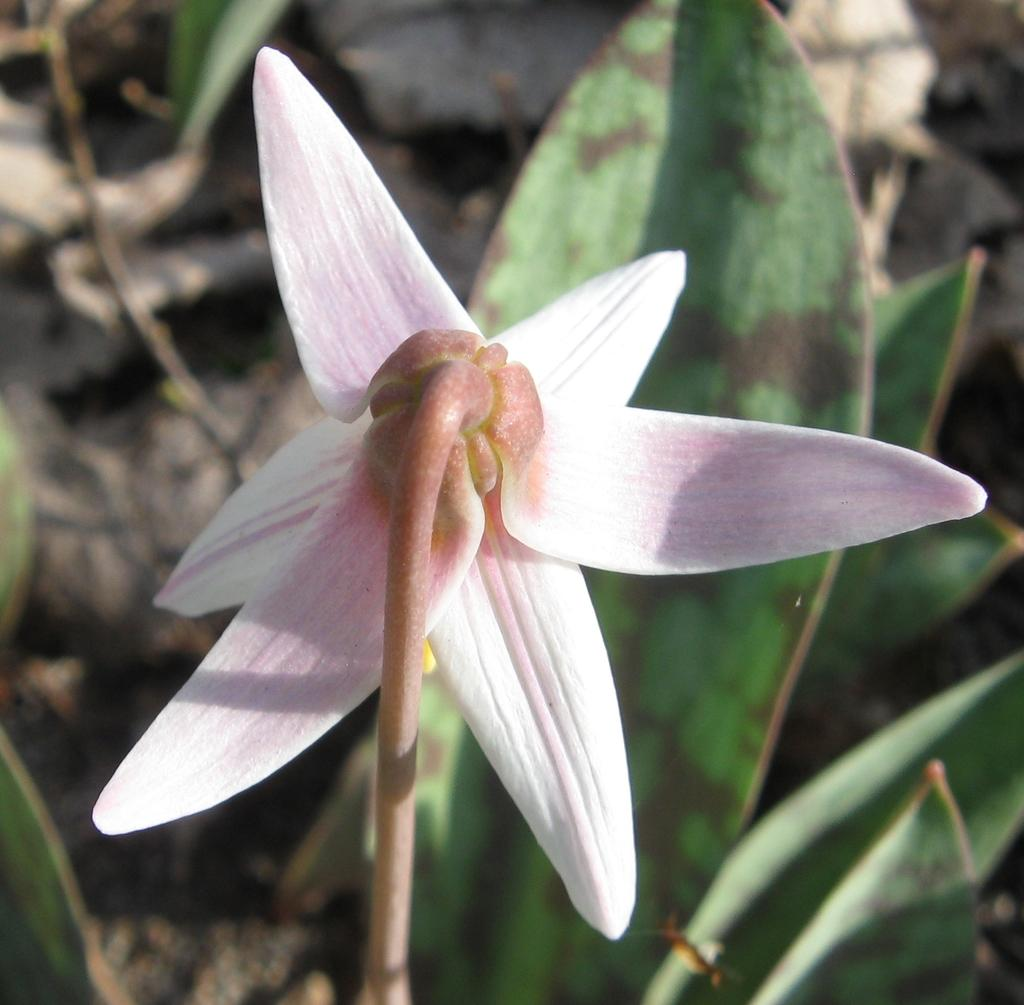What type of plant can be seen in the image? There is a flower in the image. What colors are present on the flower? The flower has white and light pink colors. What part of the flower is visible in the image? There is a stem in the image. What else is present on the flower besides the stem? There are leaves in the image. What type of comfort can be found in the flower's petals in the image? The image does not depict any comfort or sensation related to the flower's petals; it only shows the visual appearance of the flower. 